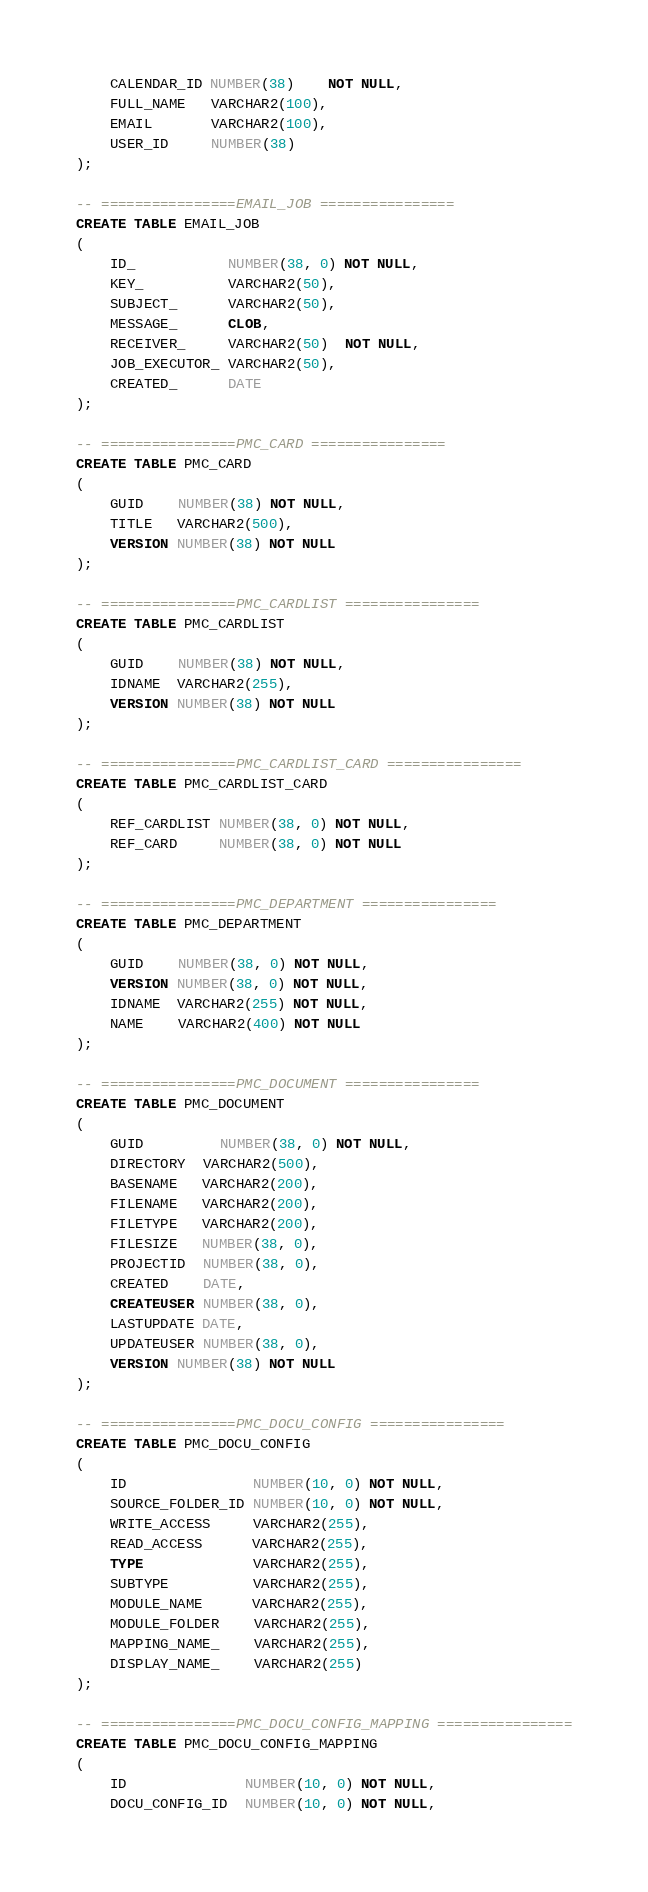<code> <loc_0><loc_0><loc_500><loc_500><_SQL_>    CALENDAR_ID NUMBER(38)    NOT NULL,
    FULL_NAME   VARCHAR2(100),
    EMAIL       VARCHAR2(100),
    USER_ID     NUMBER(38)
);

-- ================EMAIL_JOB ================
CREATE TABLE EMAIL_JOB
(
    ID_           NUMBER(38, 0) NOT NULL,
    KEY_          VARCHAR2(50),
    SUBJECT_      VARCHAR2(50),
    MESSAGE_      CLOB,
    RECEIVER_     VARCHAR2(50)  NOT NULL,
    JOB_EXECUTOR_ VARCHAR2(50),
    CREATED_      DATE
);

-- ================PMC_CARD ================
CREATE TABLE PMC_CARD
(
    GUID    NUMBER(38) NOT NULL,
    TITLE   VARCHAR2(500),
    VERSION NUMBER(38) NOT NULL
);

-- ================PMC_CARDLIST ================
CREATE TABLE PMC_CARDLIST
(
    GUID    NUMBER(38) NOT NULL,
    IDNAME  VARCHAR2(255),
    VERSION NUMBER(38) NOT NULL
);

-- ================PMC_CARDLIST_CARD ================
CREATE TABLE PMC_CARDLIST_CARD
(
    REF_CARDLIST NUMBER(38, 0) NOT NULL,
    REF_CARD     NUMBER(38, 0) NOT NULL
);

-- ================PMC_DEPARTMENT ================
CREATE TABLE PMC_DEPARTMENT
(
    GUID    NUMBER(38, 0) NOT NULL,
    VERSION NUMBER(38, 0) NOT NULL,
    IDNAME  VARCHAR2(255) NOT NULL,
    NAME    VARCHAR2(400) NOT NULL
);

-- ================PMC_DOCUMENT ================
CREATE TABLE PMC_DOCUMENT
(
    GUID         NUMBER(38, 0) NOT NULL,
    DIRECTORY  VARCHAR2(500),
    BASENAME   VARCHAR2(200),
    FILENAME   VARCHAR2(200),
    FILETYPE   VARCHAR2(200),
    FILESIZE   NUMBER(38, 0),
    PROJECTID  NUMBER(38, 0),
    CREATED    DATE,
    CREATEUSER NUMBER(38, 0),
    LASTUPDATE DATE,
    UPDATEUSER NUMBER(38, 0),
    VERSION NUMBER(38) NOT NULL
);

-- ================PMC_DOCU_CONFIG ================
CREATE TABLE PMC_DOCU_CONFIG
(
    ID               NUMBER(10, 0) NOT NULL,
    SOURCE_FOLDER_ID NUMBER(10, 0) NOT NULL,
    WRITE_ACCESS     VARCHAR2(255),
    READ_ACCESS      VARCHAR2(255),
    TYPE             VARCHAR2(255),
    SUBTYPE          VARCHAR2(255),
    MODULE_NAME      VARCHAR2(255),
    MODULE_FOLDER    VARCHAR2(255),
    MAPPING_NAME_    VARCHAR2(255),
    DISPLAY_NAME_    VARCHAR2(255)
);

-- ================PMC_DOCU_CONFIG_MAPPING ================
CREATE TABLE PMC_DOCU_CONFIG_MAPPING
(
    ID              NUMBER(10, 0) NOT NULL,
    DOCU_CONFIG_ID  NUMBER(10, 0) NOT NULL,</code> 